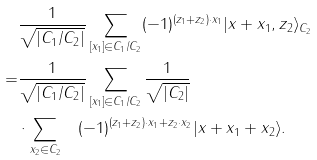Convert formula to latex. <formula><loc_0><loc_0><loc_500><loc_500>& \frac { 1 } { \sqrt { | C _ { 1 } / C _ { 2 } | } } \sum _ { [ x _ { 1 } ] \in C _ { 1 } / C _ { 2 } } ( - 1 ) ^ { ( z _ { 1 } + z _ { 2 } ) \cdot x _ { 1 } } | x + x _ { 1 } , z _ { 2 } \rangle _ { C _ { 2 } } \\ = & \frac { 1 } { \sqrt { | C _ { 1 } / C _ { 2 } | } } \sum _ { [ x _ { 1 } ] \in C _ { 1 } / C _ { 2 } } \frac { 1 } { \sqrt { | C _ { 2 } | } } \\ & \cdot \sum _ { x _ { 2 } \in C _ { 2 } } \quad ( - 1 ) ^ { ( z _ { 1 } + z _ { 2 } ) \cdot x _ { 1 } + z _ { 2 } \cdot x _ { 2 } } | x + x _ { 1 } + x _ { 2 } \rangle .</formula> 